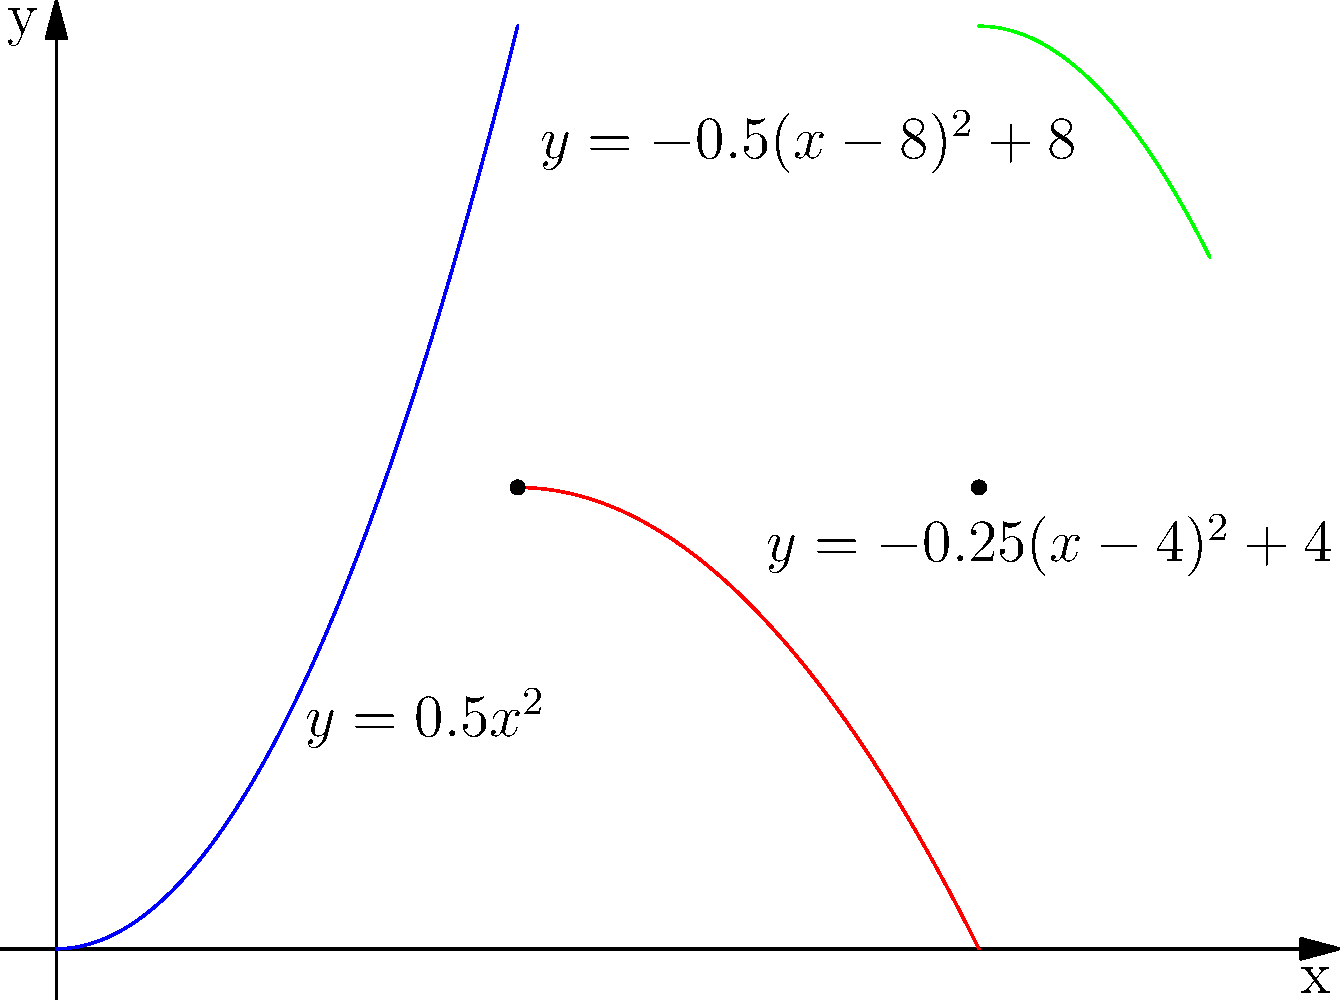A roller coaster track is designed using three piecewise polynomial functions as shown in the graph. The track is composed of:
1. $f_1(x) = 0.5x^2$ for $0 \leq x < 4$
2. $f_2(x) = -0.25(x-4)^2 + 4$ for $4 \leq x < 8$
3. $f_3(x) = -0.5(x-8)^2 + 8$ for $8 \leq x \leq 10$

At which point(s) on the track is the slope continuous? Justify your answer by calculating the slopes at the junction points. To determine where the slope is continuous, we need to calculate the slopes of each function at the junction points (x = 4 and x = 8) and compare them:

1. At x = 4:
   Slope of $f_1(x)$: $\frac{d}{dx}(0.5x^2) = x$, so at x = 4, slope = 4
   Slope of $f_2(x)$: $\frac{d}{dx}(-0.25(x-4)^2 + 4) = -0.5(x-4)$, so at x = 4, slope = 0

   The slopes are different (4 ≠ 0), so the slope is not continuous at x = 4.

2. At x = 8:
   Slope of $f_2(x)$: $\frac{d}{dx}(-0.25(x-4)^2 + 4) = -0.5(x-4)$, so at x = 8, slope = -2
   Slope of $f_3(x)$: $\frac{d}{dx}(-0.5(x-8)^2 + 8) = -(x-8)$, so at x = 8, slope = 0

   The slopes are different (-2 ≠ 0), so the slope is not continuous at x = 8.

Therefore, the slope is not continuous at any junction point on the track.
Answer: The slope is not continuous at any point on the track. 